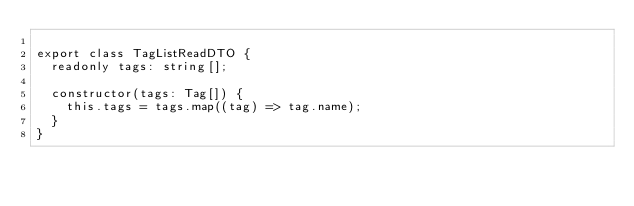Convert code to text. <code><loc_0><loc_0><loc_500><loc_500><_TypeScript_>
export class TagListReadDTO {
  readonly tags: string[];

  constructor(tags: Tag[]) {
    this.tags = tags.map((tag) => tag.name);
  }
}
</code> 